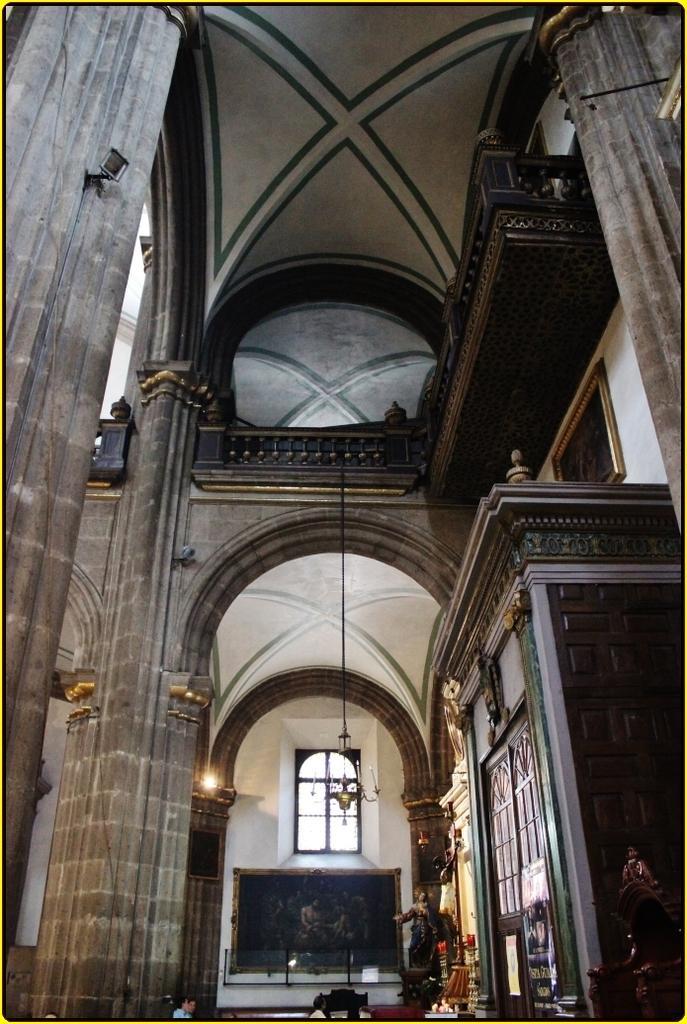How would you summarize this image in a sentence or two? This image is clicked inside. This is inside the building. There is light in the middle. There is a person in the bottom. There are doors in the right side. This is built with wood. 